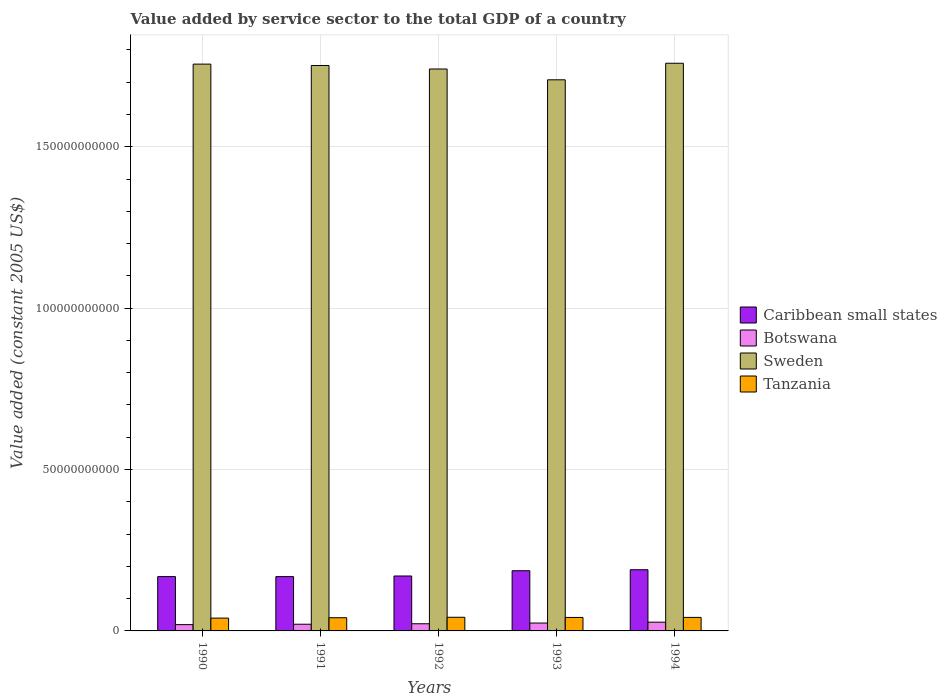How many groups of bars are there?
Make the answer very short. 5. How many bars are there on the 1st tick from the left?
Ensure brevity in your answer.  4. In how many cases, is the number of bars for a given year not equal to the number of legend labels?
Keep it short and to the point. 0. What is the value added by service sector in Tanzania in 1994?
Ensure brevity in your answer.  4.19e+09. Across all years, what is the maximum value added by service sector in Caribbean small states?
Ensure brevity in your answer.  1.90e+1. Across all years, what is the minimum value added by service sector in Botswana?
Give a very brief answer. 1.95e+09. In which year was the value added by service sector in Botswana maximum?
Provide a succinct answer. 1994. In which year was the value added by service sector in Caribbean small states minimum?
Provide a succinct answer. 1991. What is the total value added by service sector in Botswana in the graph?
Offer a very short reply. 1.14e+1. What is the difference between the value added by service sector in Botswana in 1990 and that in 1992?
Your answer should be compact. -2.69e+08. What is the difference between the value added by service sector in Sweden in 1993 and the value added by service sector in Caribbean small states in 1990?
Provide a succinct answer. 1.54e+11. What is the average value added by service sector in Botswana per year?
Your answer should be very brief. 2.28e+09. In the year 1990, what is the difference between the value added by service sector in Tanzania and value added by service sector in Sweden?
Provide a succinct answer. -1.72e+11. What is the ratio of the value added by service sector in Caribbean small states in 1991 to that in 1994?
Provide a short and direct response. 0.89. Is the value added by service sector in Caribbean small states in 1991 less than that in 1992?
Keep it short and to the point. Yes. Is the difference between the value added by service sector in Tanzania in 1992 and 1993 greater than the difference between the value added by service sector in Sweden in 1992 and 1993?
Give a very brief answer. No. What is the difference between the highest and the second highest value added by service sector in Tanzania?
Provide a short and direct response. 4.20e+07. What is the difference between the highest and the lowest value added by service sector in Botswana?
Keep it short and to the point. 7.62e+08. Is it the case that in every year, the sum of the value added by service sector in Sweden and value added by service sector in Tanzania is greater than the sum of value added by service sector in Caribbean small states and value added by service sector in Botswana?
Your answer should be compact. No. What does the 1st bar from the left in 1991 represents?
Your answer should be very brief. Caribbean small states. What does the 3rd bar from the right in 1990 represents?
Give a very brief answer. Botswana. How many bars are there?
Offer a terse response. 20. Are all the bars in the graph horizontal?
Offer a very short reply. No. How many years are there in the graph?
Offer a terse response. 5. What is the difference between two consecutive major ticks on the Y-axis?
Your response must be concise. 5.00e+1. Are the values on the major ticks of Y-axis written in scientific E-notation?
Provide a succinct answer. No. How are the legend labels stacked?
Provide a succinct answer. Vertical. What is the title of the graph?
Provide a short and direct response. Value added by service sector to the total GDP of a country. What is the label or title of the Y-axis?
Your response must be concise. Value added (constant 2005 US$). What is the Value added (constant 2005 US$) in Caribbean small states in 1990?
Provide a succinct answer. 1.68e+1. What is the Value added (constant 2005 US$) in Botswana in 1990?
Your answer should be very brief. 1.95e+09. What is the Value added (constant 2005 US$) of Sweden in 1990?
Ensure brevity in your answer.  1.76e+11. What is the Value added (constant 2005 US$) in Tanzania in 1990?
Ensure brevity in your answer.  3.97e+09. What is the Value added (constant 2005 US$) of Caribbean small states in 1991?
Give a very brief answer. 1.68e+1. What is the Value added (constant 2005 US$) in Botswana in 1991?
Your answer should be very brief. 2.07e+09. What is the Value added (constant 2005 US$) of Sweden in 1991?
Keep it short and to the point. 1.75e+11. What is the Value added (constant 2005 US$) of Tanzania in 1991?
Give a very brief answer. 4.09e+09. What is the Value added (constant 2005 US$) of Caribbean small states in 1992?
Your response must be concise. 1.70e+1. What is the Value added (constant 2005 US$) of Botswana in 1992?
Your answer should be very brief. 2.22e+09. What is the Value added (constant 2005 US$) in Sweden in 1992?
Offer a very short reply. 1.74e+11. What is the Value added (constant 2005 US$) in Tanzania in 1992?
Ensure brevity in your answer.  4.23e+09. What is the Value added (constant 2005 US$) of Caribbean small states in 1993?
Keep it short and to the point. 1.87e+1. What is the Value added (constant 2005 US$) in Botswana in 1993?
Ensure brevity in your answer.  2.44e+09. What is the Value added (constant 2005 US$) of Sweden in 1993?
Offer a terse response. 1.71e+11. What is the Value added (constant 2005 US$) of Tanzania in 1993?
Your response must be concise. 4.18e+09. What is the Value added (constant 2005 US$) of Caribbean small states in 1994?
Your answer should be compact. 1.90e+1. What is the Value added (constant 2005 US$) of Botswana in 1994?
Make the answer very short. 2.71e+09. What is the Value added (constant 2005 US$) in Sweden in 1994?
Ensure brevity in your answer.  1.76e+11. What is the Value added (constant 2005 US$) of Tanzania in 1994?
Your answer should be very brief. 4.19e+09. Across all years, what is the maximum Value added (constant 2005 US$) in Caribbean small states?
Make the answer very short. 1.90e+1. Across all years, what is the maximum Value added (constant 2005 US$) of Botswana?
Provide a succinct answer. 2.71e+09. Across all years, what is the maximum Value added (constant 2005 US$) of Sweden?
Your answer should be compact. 1.76e+11. Across all years, what is the maximum Value added (constant 2005 US$) in Tanzania?
Keep it short and to the point. 4.23e+09. Across all years, what is the minimum Value added (constant 2005 US$) of Caribbean small states?
Provide a succinct answer. 1.68e+1. Across all years, what is the minimum Value added (constant 2005 US$) in Botswana?
Give a very brief answer. 1.95e+09. Across all years, what is the minimum Value added (constant 2005 US$) of Sweden?
Make the answer very short. 1.71e+11. Across all years, what is the minimum Value added (constant 2005 US$) of Tanzania?
Your answer should be very brief. 3.97e+09. What is the total Value added (constant 2005 US$) of Caribbean small states in the graph?
Give a very brief answer. 8.83e+1. What is the total Value added (constant 2005 US$) of Botswana in the graph?
Your answer should be compact. 1.14e+1. What is the total Value added (constant 2005 US$) of Sweden in the graph?
Give a very brief answer. 8.72e+11. What is the total Value added (constant 2005 US$) of Tanzania in the graph?
Your response must be concise. 2.07e+1. What is the difference between the Value added (constant 2005 US$) in Caribbean small states in 1990 and that in 1991?
Make the answer very short. 5.15e+06. What is the difference between the Value added (constant 2005 US$) in Botswana in 1990 and that in 1991?
Keep it short and to the point. -1.25e+08. What is the difference between the Value added (constant 2005 US$) in Sweden in 1990 and that in 1991?
Your answer should be very brief. 4.27e+08. What is the difference between the Value added (constant 2005 US$) of Tanzania in 1990 and that in 1991?
Provide a succinct answer. -1.18e+08. What is the difference between the Value added (constant 2005 US$) in Caribbean small states in 1990 and that in 1992?
Offer a very short reply. -1.83e+08. What is the difference between the Value added (constant 2005 US$) of Botswana in 1990 and that in 1992?
Provide a short and direct response. -2.69e+08. What is the difference between the Value added (constant 2005 US$) of Sweden in 1990 and that in 1992?
Ensure brevity in your answer.  1.51e+09. What is the difference between the Value added (constant 2005 US$) of Tanzania in 1990 and that in 1992?
Your answer should be compact. -2.59e+08. What is the difference between the Value added (constant 2005 US$) of Caribbean small states in 1990 and that in 1993?
Give a very brief answer. -1.82e+09. What is the difference between the Value added (constant 2005 US$) in Botswana in 1990 and that in 1993?
Keep it short and to the point. -4.92e+08. What is the difference between the Value added (constant 2005 US$) in Sweden in 1990 and that in 1993?
Your answer should be compact. 4.86e+09. What is the difference between the Value added (constant 2005 US$) in Tanzania in 1990 and that in 1993?
Your answer should be compact. -2.03e+08. What is the difference between the Value added (constant 2005 US$) in Caribbean small states in 1990 and that in 1994?
Your answer should be compact. -2.13e+09. What is the difference between the Value added (constant 2005 US$) of Botswana in 1990 and that in 1994?
Your answer should be compact. -7.62e+08. What is the difference between the Value added (constant 2005 US$) in Sweden in 1990 and that in 1994?
Ensure brevity in your answer.  -2.67e+08. What is the difference between the Value added (constant 2005 US$) in Tanzania in 1990 and that in 1994?
Your answer should be very brief. -2.17e+08. What is the difference between the Value added (constant 2005 US$) in Caribbean small states in 1991 and that in 1992?
Your answer should be compact. -1.89e+08. What is the difference between the Value added (constant 2005 US$) of Botswana in 1991 and that in 1992?
Give a very brief answer. -1.44e+08. What is the difference between the Value added (constant 2005 US$) in Sweden in 1991 and that in 1992?
Provide a short and direct response. 1.08e+09. What is the difference between the Value added (constant 2005 US$) in Tanzania in 1991 and that in 1992?
Provide a short and direct response. -1.41e+08. What is the difference between the Value added (constant 2005 US$) in Caribbean small states in 1991 and that in 1993?
Provide a succinct answer. -1.82e+09. What is the difference between the Value added (constant 2005 US$) of Botswana in 1991 and that in 1993?
Your answer should be compact. -3.67e+08. What is the difference between the Value added (constant 2005 US$) in Sweden in 1991 and that in 1993?
Provide a short and direct response. 4.43e+09. What is the difference between the Value added (constant 2005 US$) of Tanzania in 1991 and that in 1993?
Give a very brief answer. -8.57e+07. What is the difference between the Value added (constant 2005 US$) of Caribbean small states in 1991 and that in 1994?
Provide a short and direct response. -2.13e+09. What is the difference between the Value added (constant 2005 US$) in Botswana in 1991 and that in 1994?
Your answer should be very brief. -6.38e+08. What is the difference between the Value added (constant 2005 US$) in Sweden in 1991 and that in 1994?
Give a very brief answer. -6.95e+08. What is the difference between the Value added (constant 2005 US$) of Tanzania in 1991 and that in 1994?
Provide a succinct answer. -9.90e+07. What is the difference between the Value added (constant 2005 US$) of Caribbean small states in 1992 and that in 1993?
Provide a short and direct response. -1.63e+09. What is the difference between the Value added (constant 2005 US$) of Botswana in 1992 and that in 1993?
Your answer should be very brief. -2.23e+08. What is the difference between the Value added (constant 2005 US$) in Sweden in 1992 and that in 1993?
Give a very brief answer. 3.35e+09. What is the difference between the Value added (constant 2005 US$) of Tanzania in 1992 and that in 1993?
Give a very brief answer. 5.52e+07. What is the difference between the Value added (constant 2005 US$) of Caribbean small states in 1992 and that in 1994?
Your answer should be very brief. -1.94e+09. What is the difference between the Value added (constant 2005 US$) of Botswana in 1992 and that in 1994?
Offer a terse response. -4.93e+08. What is the difference between the Value added (constant 2005 US$) of Sweden in 1992 and that in 1994?
Provide a succinct answer. -1.78e+09. What is the difference between the Value added (constant 2005 US$) of Tanzania in 1992 and that in 1994?
Make the answer very short. 4.20e+07. What is the difference between the Value added (constant 2005 US$) in Caribbean small states in 1993 and that in 1994?
Provide a short and direct response. -3.07e+08. What is the difference between the Value added (constant 2005 US$) in Botswana in 1993 and that in 1994?
Provide a short and direct response. -2.71e+08. What is the difference between the Value added (constant 2005 US$) of Sweden in 1993 and that in 1994?
Offer a very short reply. -5.13e+09. What is the difference between the Value added (constant 2005 US$) in Tanzania in 1993 and that in 1994?
Your answer should be very brief. -1.32e+07. What is the difference between the Value added (constant 2005 US$) of Caribbean small states in 1990 and the Value added (constant 2005 US$) of Botswana in 1991?
Your answer should be compact. 1.48e+1. What is the difference between the Value added (constant 2005 US$) in Caribbean small states in 1990 and the Value added (constant 2005 US$) in Sweden in 1991?
Your answer should be very brief. -1.58e+11. What is the difference between the Value added (constant 2005 US$) in Caribbean small states in 1990 and the Value added (constant 2005 US$) in Tanzania in 1991?
Offer a very short reply. 1.27e+1. What is the difference between the Value added (constant 2005 US$) in Botswana in 1990 and the Value added (constant 2005 US$) in Sweden in 1991?
Offer a very short reply. -1.73e+11. What is the difference between the Value added (constant 2005 US$) in Botswana in 1990 and the Value added (constant 2005 US$) in Tanzania in 1991?
Offer a terse response. -2.14e+09. What is the difference between the Value added (constant 2005 US$) in Sweden in 1990 and the Value added (constant 2005 US$) in Tanzania in 1991?
Keep it short and to the point. 1.72e+11. What is the difference between the Value added (constant 2005 US$) in Caribbean small states in 1990 and the Value added (constant 2005 US$) in Botswana in 1992?
Keep it short and to the point. 1.46e+1. What is the difference between the Value added (constant 2005 US$) in Caribbean small states in 1990 and the Value added (constant 2005 US$) in Sweden in 1992?
Your answer should be compact. -1.57e+11. What is the difference between the Value added (constant 2005 US$) of Caribbean small states in 1990 and the Value added (constant 2005 US$) of Tanzania in 1992?
Keep it short and to the point. 1.26e+1. What is the difference between the Value added (constant 2005 US$) in Botswana in 1990 and the Value added (constant 2005 US$) in Sweden in 1992?
Ensure brevity in your answer.  -1.72e+11. What is the difference between the Value added (constant 2005 US$) in Botswana in 1990 and the Value added (constant 2005 US$) in Tanzania in 1992?
Your answer should be very brief. -2.28e+09. What is the difference between the Value added (constant 2005 US$) of Sweden in 1990 and the Value added (constant 2005 US$) of Tanzania in 1992?
Make the answer very short. 1.71e+11. What is the difference between the Value added (constant 2005 US$) in Caribbean small states in 1990 and the Value added (constant 2005 US$) in Botswana in 1993?
Your answer should be very brief. 1.44e+1. What is the difference between the Value added (constant 2005 US$) in Caribbean small states in 1990 and the Value added (constant 2005 US$) in Sweden in 1993?
Your answer should be very brief. -1.54e+11. What is the difference between the Value added (constant 2005 US$) of Caribbean small states in 1990 and the Value added (constant 2005 US$) of Tanzania in 1993?
Offer a terse response. 1.27e+1. What is the difference between the Value added (constant 2005 US$) of Botswana in 1990 and the Value added (constant 2005 US$) of Sweden in 1993?
Your answer should be very brief. -1.69e+11. What is the difference between the Value added (constant 2005 US$) of Botswana in 1990 and the Value added (constant 2005 US$) of Tanzania in 1993?
Keep it short and to the point. -2.23e+09. What is the difference between the Value added (constant 2005 US$) of Sweden in 1990 and the Value added (constant 2005 US$) of Tanzania in 1993?
Your answer should be compact. 1.71e+11. What is the difference between the Value added (constant 2005 US$) of Caribbean small states in 1990 and the Value added (constant 2005 US$) of Botswana in 1994?
Give a very brief answer. 1.41e+1. What is the difference between the Value added (constant 2005 US$) in Caribbean small states in 1990 and the Value added (constant 2005 US$) in Sweden in 1994?
Your answer should be compact. -1.59e+11. What is the difference between the Value added (constant 2005 US$) in Caribbean small states in 1990 and the Value added (constant 2005 US$) in Tanzania in 1994?
Your answer should be very brief. 1.26e+1. What is the difference between the Value added (constant 2005 US$) in Botswana in 1990 and the Value added (constant 2005 US$) in Sweden in 1994?
Ensure brevity in your answer.  -1.74e+11. What is the difference between the Value added (constant 2005 US$) in Botswana in 1990 and the Value added (constant 2005 US$) in Tanzania in 1994?
Your answer should be very brief. -2.24e+09. What is the difference between the Value added (constant 2005 US$) in Sweden in 1990 and the Value added (constant 2005 US$) in Tanzania in 1994?
Give a very brief answer. 1.71e+11. What is the difference between the Value added (constant 2005 US$) of Caribbean small states in 1991 and the Value added (constant 2005 US$) of Botswana in 1992?
Provide a short and direct response. 1.46e+1. What is the difference between the Value added (constant 2005 US$) in Caribbean small states in 1991 and the Value added (constant 2005 US$) in Sweden in 1992?
Provide a short and direct response. -1.57e+11. What is the difference between the Value added (constant 2005 US$) of Caribbean small states in 1991 and the Value added (constant 2005 US$) of Tanzania in 1992?
Make the answer very short. 1.26e+1. What is the difference between the Value added (constant 2005 US$) in Botswana in 1991 and the Value added (constant 2005 US$) in Sweden in 1992?
Your answer should be very brief. -1.72e+11. What is the difference between the Value added (constant 2005 US$) of Botswana in 1991 and the Value added (constant 2005 US$) of Tanzania in 1992?
Ensure brevity in your answer.  -2.16e+09. What is the difference between the Value added (constant 2005 US$) in Sweden in 1991 and the Value added (constant 2005 US$) in Tanzania in 1992?
Give a very brief answer. 1.71e+11. What is the difference between the Value added (constant 2005 US$) of Caribbean small states in 1991 and the Value added (constant 2005 US$) of Botswana in 1993?
Your response must be concise. 1.44e+1. What is the difference between the Value added (constant 2005 US$) in Caribbean small states in 1991 and the Value added (constant 2005 US$) in Sweden in 1993?
Your response must be concise. -1.54e+11. What is the difference between the Value added (constant 2005 US$) in Caribbean small states in 1991 and the Value added (constant 2005 US$) in Tanzania in 1993?
Give a very brief answer. 1.27e+1. What is the difference between the Value added (constant 2005 US$) of Botswana in 1991 and the Value added (constant 2005 US$) of Sweden in 1993?
Give a very brief answer. -1.69e+11. What is the difference between the Value added (constant 2005 US$) of Botswana in 1991 and the Value added (constant 2005 US$) of Tanzania in 1993?
Make the answer very short. -2.10e+09. What is the difference between the Value added (constant 2005 US$) in Sweden in 1991 and the Value added (constant 2005 US$) in Tanzania in 1993?
Make the answer very short. 1.71e+11. What is the difference between the Value added (constant 2005 US$) of Caribbean small states in 1991 and the Value added (constant 2005 US$) of Botswana in 1994?
Provide a short and direct response. 1.41e+1. What is the difference between the Value added (constant 2005 US$) of Caribbean small states in 1991 and the Value added (constant 2005 US$) of Sweden in 1994?
Offer a terse response. -1.59e+11. What is the difference between the Value added (constant 2005 US$) of Caribbean small states in 1991 and the Value added (constant 2005 US$) of Tanzania in 1994?
Give a very brief answer. 1.26e+1. What is the difference between the Value added (constant 2005 US$) of Botswana in 1991 and the Value added (constant 2005 US$) of Sweden in 1994?
Keep it short and to the point. -1.74e+11. What is the difference between the Value added (constant 2005 US$) of Botswana in 1991 and the Value added (constant 2005 US$) of Tanzania in 1994?
Provide a succinct answer. -2.11e+09. What is the difference between the Value added (constant 2005 US$) of Sweden in 1991 and the Value added (constant 2005 US$) of Tanzania in 1994?
Provide a succinct answer. 1.71e+11. What is the difference between the Value added (constant 2005 US$) in Caribbean small states in 1992 and the Value added (constant 2005 US$) in Botswana in 1993?
Make the answer very short. 1.46e+1. What is the difference between the Value added (constant 2005 US$) of Caribbean small states in 1992 and the Value added (constant 2005 US$) of Sweden in 1993?
Provide a succinct answer. -1.54e+11. What is the difference between the Value added (constant 2005 US$) in Caribbean small states in 1992 and the Value added (constant 2005 US$) in Tanzania in 1993?
Offer a very short reply. 1.28e+1. What is the difference between the Value added (constant 2005 US$) of Botswana in 1992 and the Value added (constant 2005 US$) of Sweden in 1993?
Keep it short and to the point. -1.69e+11. What is the difference between the Value added (constant 2005 US$) in Botswana in 1992 and the Value added (constant 2005 US$) in Tanzania in 1993?
Offer a terse response. -1.96e+09. What is the difference between the Value added (constant 2005 US$) of Sweden in 1992 and the Value added (constant 2005 US$) of Tanzania in 1993?
Give a very brief answer. 1.70e+11. What is the difference between the Value added (constant 2005 US$) of Caribbean small states in 1992 and the Value added (constant 2005 US$) of Botswana in 1994?
Give a very brief answer. 1.43e+1. What is the difference between the Value added (constant 2005 US$) of Caribbean small states in 1992 and the Value added (constant 2005 US$) of Sweden in 1994?
Your response must be concise. -1.59e+11. What is the difference between the Value added (constant 2005 US$) of Caribbean small states in 1992 and the Value added (constant 2005 US$) of Tanzania in 1994?
Keep it short and to the point. 1.28e+1. What is the difference between the Value added (constant 2005 US$) in Botswana in 1992 and the Value added (constant 2005 US$) in Sweden in 1994?
Provide a short and direct response. -1.74e+11. What is the difference between the Value added (constant 2005 US$) in Botswana in 1992 and the Value added (constant 2005 US$) in Tanzania in 1994?
Make the answer very short. -1.97e+09. What is the difference between the Value added (constant 2005 US$) of Sweden in 1992 and the Value added (constant 2005 US$) of Tanzania in 1994?
Provide a succinct answer. 1.70e+11. What is the difference between the Value added (constant 2005 US$) in Caribbean small states in 1993 and the Value added (constant 2005 US$) in Botswana in 1994?
Keep it short and to the point. 1.59e+1. What is the difference between the Value added (constant 2005 US$) in Caribbean small states in 1993 and the Value added (constant 2005 US$) in Sweden in 1994?
Keep it short and to the point. -1.57e+11. What is the difference between the Value added (constant 2005 US$) in Caribbean small states in 1993 and the Value added (constant 2005 US$) in Tanzania in 1994?
Offer a terse response. 1.45e+1. What is the difference between the Value added (constant 2005 US$) in Botswana in 1993 and the Value added (constant 2005 US$) in Sweden in 1994?
Your answer should be very brief. -1.73e+11. What is the difference between the Value added (constant 2005 US$) of Botswana in 1993 and the Value added (constant 2005 US$) of Tanzania in 1994?
Ensure brevity in your answer.  -1.75e+09. What is the difference between the Value added (constant 2005 US$) of Sweden in 1993 and the Value added (constant 2005 US$) of Tanzania in 1994?
Give a very brief answer. 1.67e+11. What is the average Value added (constant 2005 US$) of Caribbean small states per year?
Make the answer very short. 1.77e+1. What is the average Value added (constant 2005 US$) of Botswana per year?
Provide a succinct answer. 2.28e+09. What is the average Value added (constant 2005 US$) in Sweden per year?
Your answer should be compact. 1.74e+11. What is the average Value added (constant 2005 US$) of Tanzania per year?
Your answer should be compact. 4.13e+09. In the year 1990, what is the difference between the Value added (constant 2005 US$) of Caribbean small states and Value added (constant 2005 US$) of Botswana?
Keep it short and to the point. 1.49e+1. In the year 1990, what is the difference between the Value added (constant 2005 US$) of Caribbean small states and Value added (constant 2005 US$) of Sweden?
Your answer should be very brief. -1.59e+11. In the year 1990, what is the difference between the Value added (constant 2005 US$) in Caribbean small states and Value added (constant 2005 US$) in Tanzania?
Keep it short and to the point. 1.29e+1. In the year 1990, what is the difference between the Value added (constant 2005 US$) of Botswana and Value added (constant 2005 US$) of Sweden?
Make the answer very short. -1.74e+11. In the year 1990, what is the difference between the Value added (constant 2005 US$) in Botswana and Value added (constant 2005 US$) in Tanzania?
Keep it short and to the point. -2.02e+09. In the year 1990, what is the difference between the Value added (constant 2005 US$) of Sweden and Value added (constant 2005 US$) of Tanzania?
Provide a succinct answer. 1.72e+11. In the year 1991, what is the difference between the Value added (constant 2005 US$) of Caribbean small states and Value added (constant 2005 US$) of Botswana?
Provide a succinct answer. 1.48e+1. In the year 1991, what is the difference between the Value added (constant 2005 US$) of Caribbean small states and Value added (constant 2005 US$) of Sweden?
Make the answer very short. -1.58e+11. In the year 1991, what is the difference between the Value added (constant 2005 US$) in Caribbean small states and Value added (constant 2005 US$) in Tanzania?
Your answer should be very brief. 1.27e+1. In the year 1991, what is the difference between the Value added (constant 2005 US$) of Botswana and Value added (constant 2005 US$) of Sweden?
Your response must be concise. -1.73e+11. In the year 1991, what is the difference between the Value added (constant 2005 US$) of Botswana and Value added (constant 2005 US$) of Tanzania?
Your answer should be compact. -2.02e+09. In the year 1991, what is the difference between the Value added (constant 2005 US$) in Sweden and Value added (constant 2005 US$) in Tanzania?
Keep it short and to the point. 1.71e+11. In the year 1992, what is the difference between the Value added (constant 2005 US$) of Caribbean small states and Value added (constant 2005 US$) of Botswana?
Keep it short and to the point. 1.48e+1. In the year 1992, what is the difference between the Value added (constant 2005 US$) in Caribbean small states and Value added (constant 2005 US$) in Sweden?
Keep it short and to the point. -1.57e+11. In the year 1992, what is the difference between the Value added (constant 2005 US$) of Caribbean small states and Value added (constant 2005 US$) of Tanzania?
Provide a succinct answer. 1.28e+1. In the year 1992, what is the difference between the Value added (constant 2005 US$) of Botswana and Value added (constant 2005 US$) of Sweden?
Give a very brief answer. -1.72e+11. In the year 1992, what is the difference between the Value added (constant 2005 US$) in Botswana and Value added (constant 2005 US$) in Tanzania?
Offer a very short reply. -2.01e+09. In the year 1992, what is the difference between the Value added (constant 2005 US$) of Sweden and Value added (constant 2005 US$) of Tanzania?
Keep it short and to the point. 1.70e+11. In the year 1993, what is the difference between the Value added (constant 2005 US$) in Caribbean small states and Value added (constant 2005 US$) in Botswana?
Provide a succinct answer. 1.62e+1. In the year 1993, what is the difference between the Value added (constant 2005 US$) of Caribbean small states and Value added (constant 2005 US$) of Sweden?
Ensure brevity in your answer.  -1.52e+11. In the year 1993, what is the difference between the Value added (constant 2005 US$) in Caribbean small states and Value added (constant 2005 US$) in Tanzania?
Your answer should be very brief. 1.45e+1. In the year 1993, what is the difference between the Value added (constant 2005 US$) of Botswana and Value added (constant 2005 US$) of Sweden?
Your answer should be very brief. -1.68e+11. In the year 1993, what is the difference between the Value added (constant 2005 US$) in Botswana and Value added (constant 2005 US$) in Tanzania?
Offer a terse response. -1.73e+09. In the year 1993, what is the difference between the Value added (constant 2005 US$) in Sweden and Value added (constant 2005 US$) in Tanzania?
Offer a terse response. 1.67e+11. In the year 1994, what is the difference between the Value added (constant 2005 US$) of Caribbean small states and Value added (constant 2005 US$) of Botswana?
Offer a very short reply. 1.62e+1. In the year 1994, what is the difference between the Value added (constant 2005 US$) in Caribbean small states and Value added (constant 2005 US$) in Sweden?
Provide a succinct answer. -1.57e+11. In the year 1994, what is the difference between the Value added (constant 2005 US$) in Caribbean small states and Value added (constant 2005 US$) in Tanzania?
Keep it short and to the point. 1.48e+1. In the year 1994, what is the difference between the Value added (constant 2005 US$) in Botswana and Value added (constant 2005 US$) in Sweden?
Your response must be concise. -1.73e+11. In the year 1994, what is the difference between the Value added (constant 2005 US$) in Botswana and Value added (constant 2005 US$) in Tanzania?
Provide a short and direct response. -1.48e+09. In the year 1994, what is the difference between the Value added (constant 2005 US$) in Sweden and Value added (constant 2005 US$) in Tanzania?
Provide a short and direct response. 1.72e+11. What is the ratio of the Value added (constant 2005 US$) in Botswana in 1990 to that in 1991?
Provide a succinct answer. 0.94. What is the ratio of the Value added (constant 2005 US$) of Sweden in 1990 to that in 1991?
Your response must be concise. 1. What is the ratio of the Value added (constant 2005 US$) in Tanzania in 1990 to that in 1991?
Give a very brief answer. 0.97. What is the ratio of the Value added (constant 2005 US$) in Caribbean small states in 1990 to that in 1992?
Provide a succinct answer. 0.99. What is the ratio of the Value added (constant 2005 US$) in Botswana in 1990 to that in 1992?
Keep it short and to the point. 0.88. What is the ratio of the Value added (constant 2005 US$) of Sweden in 1990 to that in 1992?
Your answer should be very brief. 1.01. What is the ratio of the Value added (constant 2005 US$) in Tanzania in 1990 to that in 1992?
Give a very brief answer. 0.94. What is the ratio of the Value added (constant 2005 US$) of Caribbean small states in 1990 to that in 1993?
Give a very brief answer. 0.9. What is the ratio of the Value added (constant 2005 US$) in Botswana in 1990 to that in 1993?
Ensure brevity in your answer.  0.8. What is the ratio of the Value added (constant 2005 US$) of Sweden in 1990 to that in 1993?
Offer a terse response. 1.03. What is the ratio of the Value added (constant 2005 US$) in Tanzania in 1990 to that in 1993?
Provide a succinct answer. 0.95. What is the ratio of the Value added (constant 2005 US$) of Caribbean small states in 1990 to that in 1994?
Make the answer very short. 0.89. What is the ratio of the Value added (constant 2005 US$) of Botswana in 1990 to that in 1994?
Provide a short and direct response. 0.72. What is the ratio of the Value added (constant 2005 US$) in Tanzania in 1990 to that in 1994?
Keep it short and to the point. 0.95. What is the ratio of the Value added (constant 2005 US$) of Caribbean small states in 1991 to that in 1992?
Your response must be concise. 0.99. What is the ratio of the Value added (constant 2005 US$) in Botswana in 1991 to that in 1992?
Your answer should be very brief. 0.93. What is the ratio of the Value added (constant 2005 US$) in Sweden in 1991 to that in 1992?
Provide a short and direct response. 1.01. What is the ratio of the Value added (constant 2005 US$) of Tanzania in 1991 to that in 1992?
Your answer should be compact. 0.97. What is the ratio of the Value added (constant 2005 US$) in Caribbean small states in 1991 to that in 1993?
Provide a short and direct response. 0.9. What is the ratio of the Value added (constant 2005 US$) in Botswana in 1991 to that in 1993?
Keep it short and to the point. 0.85. What is the ratio of the Value added (constant 2005 US$) in Tanzania in 1991 to that in 1993?
Provide a succinct answer. 0.98. What is the ratio of the Value added (constant 2005 US$) of Caribbean small states in 1991 to that in 1994?
Keep it short and to the point. 0.89. What is the ratio of the Value added (constant 2005 US$) of Botswana in 1991 to that in 1994?
Offer a very short reply. 0.76. What is the ratio of the Value added (constant 2005 US$) of Tanzania in 1991 to that in 1994?
Your answer should be very brief. 0.98. What is the ratio of the Value added (constant 2005 US$) of Caribbean small states in 1992 to that in 1993?
Keep it short and to the point. 0.91. What is the ratio of the Value added (constant 2005 US$) of Botswana in 1992 to that in 1993?
Your response must be concise. 0.91. What is the ratio of the Value added (constant 2005 US$) of Sweden in 1992 to that in 1993?
Offer a very short reply. 1.02. What is the ratio of the Value added (constant 2005 US$) in Tanzania in 1992 to that in 1993?
Your response must be concise. 1.01. What is the ratio of the Value added (constant 2005 US$) in Caribbean small states in 1992 to that in 1994?
Provide a short and direct response. 0.9. What is the ratio of the Value added (constant 2005 US$) of Botswana in 1992 to that in 1994?
Your response must be concise. 0.82. What is the ratio of the Value added (constant 2005 US$) in Sweden in 1992 to that in 1994?
Provide a succinct answer. 0.99. What is the ratio of the Value added (constant 2005 US$) of Caribbean small states in 1993 to that in 1994?
Make the answer very short. 0.98. What is the ratio of the Value added (constant 2005 US$) of Botswana in 1993 to that in 1994?
Keep it short and to the point. 0.9. What is the ratio of the Value added (constant 2005 US$) in Sweden in 1993 to that in 1994?
Provide a short and direct response. 0.97. What is the difference between the highest and the second highest Value added (constant 2005 US$) in Caribbean small states?
Your answer should be very brief. 3.07e+08. What is the difference between the highest and the second highest Value added (constant 2005 US$) in Botswana?
Keep it short and to the point. 2.71e+08. What is the difference between the highest and the second highest Value added (constant 2005 US$) in Sweden?
Your answer should be compact. 2.67e+08. What is the difference between the highest and the second highest Value added (constant 2005 US$) of Tanzania?
Provide a succinct answer. 4.20e+07. What is the difference between the highest and the lowest Value added (constant 2005 US$) of Caribbean small states?
Keep it short and to the point. 2.13e+09. What is the difference between the highest and the lowest Value added (constant 2005 US$) in Botswana?
Make the answer very short. 7.62e+08. What is the difference between the highest and the lowest Value added (constant 2005 US$) of Sweden?
Provide a succinct answer. 5.13e+09. What is the difference between the highest and the lowest Value added (constant 2005 US$) in Tanzania?
Offer a very short reply. 2.59e+08. 